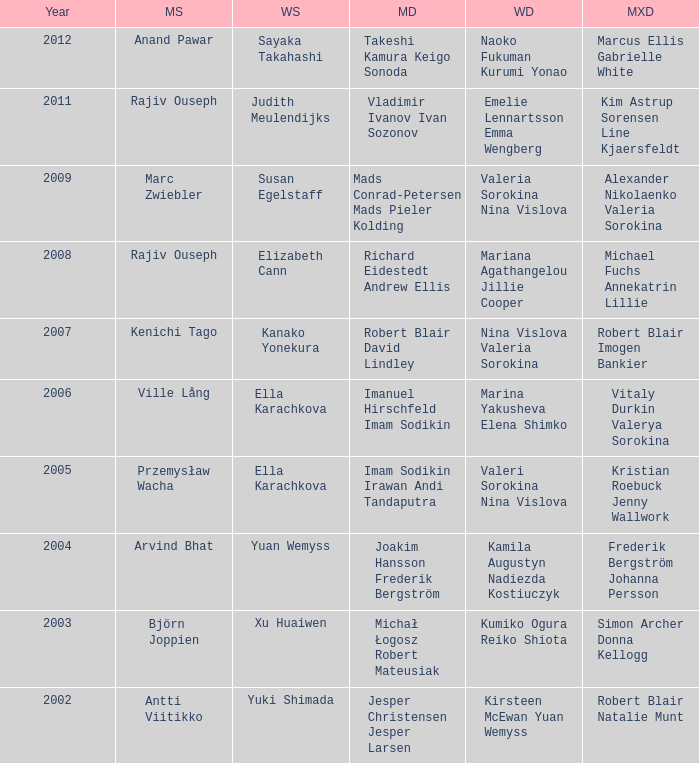Name the men's singles of marina yakusheva elena shimko Ville Lång. 